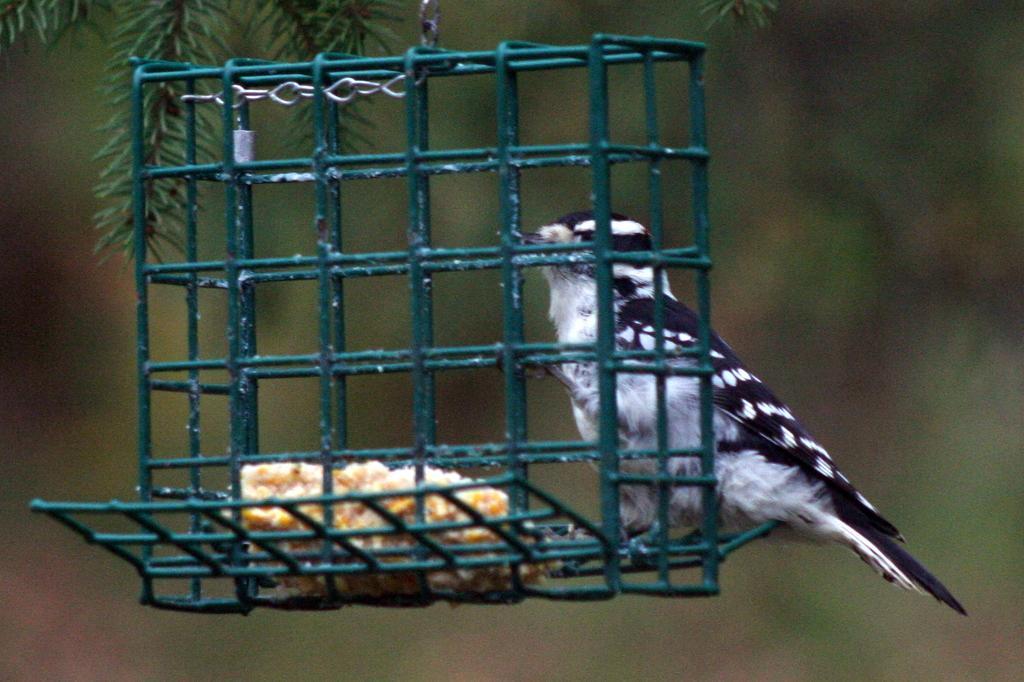Describe this image in one or two sentences. In this image I can see green colour iron stand and on it I can see cream colour food and a bird. I can see colour of this bird is white and black. In background I can see green colour leaves and I can see this image is blurry from background. 